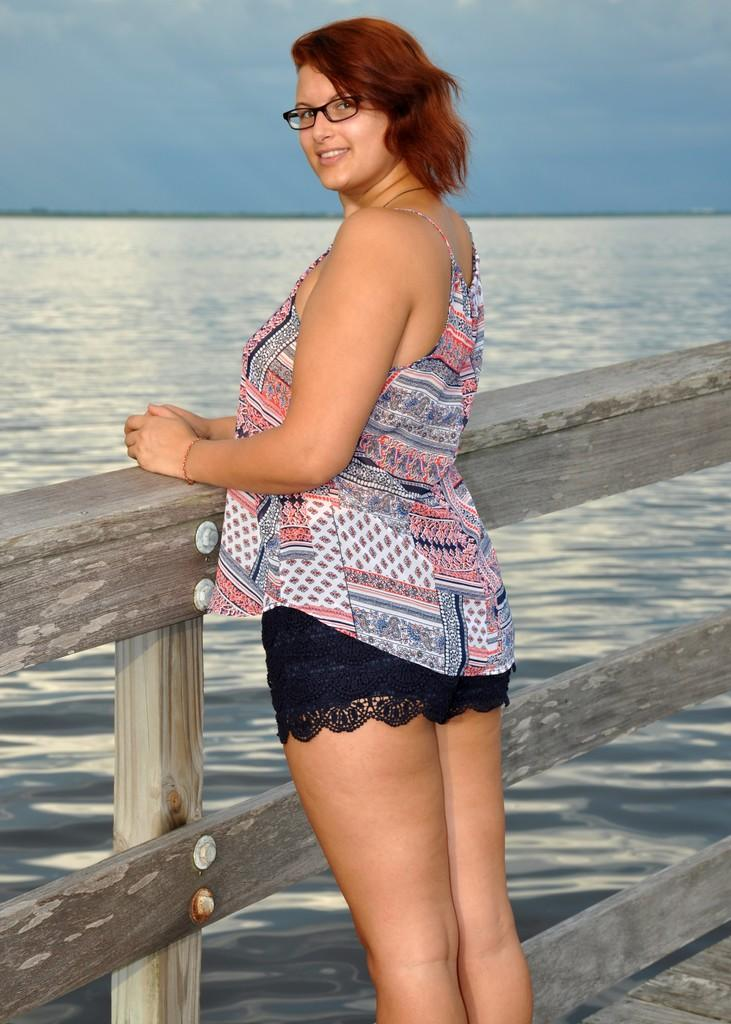Who is present in the image? There is a woman in the image. Where is the woman located in the image? The woman is standing on a walkway bridge. What can be seen in the background of the image? There is water and the sky visible in the background of the image. What type of wool is being spun by the woman in the image? There is no wool or spinning activity present in the image; the woman is standing on a walkway bridge. What type of sea creatures can be seen swimming in the water in the image? There are no sea creatures visible in the image; only water is visible in the background. 